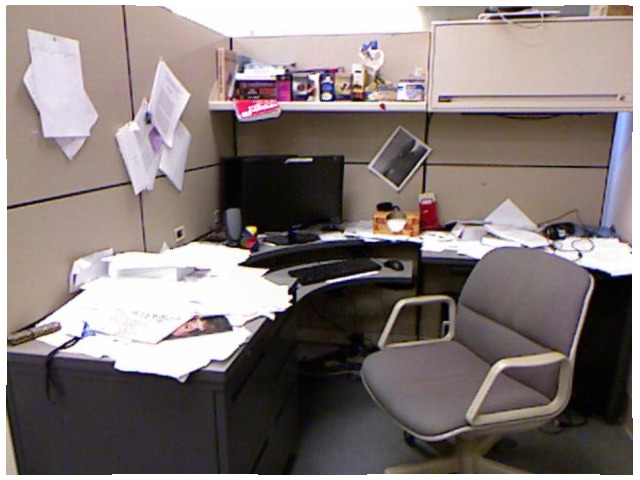<image>
Can you confirm if the chair is in front of the papers? Yes. The chair is positioned in front of the papers, appearing closer to the camera viewpoint. Where is the paper in relation to the desk? Is it on the desk? No. The paper is not positioned on the desk. They may be near each other, but the paper is not supported by or resting on top of the desk. Is there a paper behind the chair? No. The paper is not behind the chair. From this viewpoint, the paper appears to be positioned elsewhere in the scene. Where is the monitor in relation to the keyboard? Is it above the keyboard? Yes. The monitor is positioned above the keyboard in the vertical space, higher up in the scene. Where is the chair in relation to the papers? Is it next to the papers? Yes. The chair is positioned adjacent to the papers, located nearby in the same general area. 